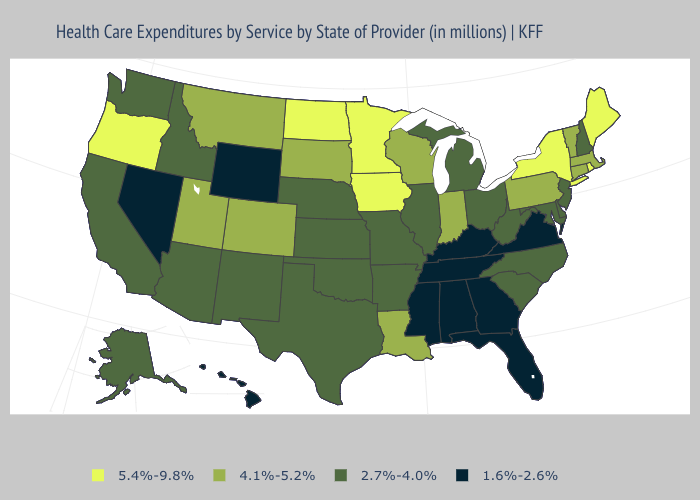What is the value of New York?
Give a very brief answer. 5.4%-9.8%. Does Nebraska have a higher value than New York?
Keep it brief. No. Name the states that have a value in the range 5.4%-9.8%?
Be succinct. Iowa, Maine, Minnesota, New York, North Dakota, Oregon, Rhode Island. What is the value of Wisconsin?
Write a very short answer. 4.1%-5.2%. Among the states that border Nevada , does Oregon have the highest value?
Short answer required. Yes. What is the value of Wisconsin?
Write a very short answer. 4.1%-5.2%. Does Massachusetts have the lowest value in the Northeast?
Answer briefly. No. What is the value of Hawaii?
Short answer required. 1.6%-2.6%. Name the states that have a value in the range 4.1%-5.2%?
Be succinct. Colorado, Connecticut, Indiana, Louisiana, Massachusetts, Montana, Pennsylvania, South Dakota, Utah, Vermont, Wisconsin. Name the states that have a value in the range 1.6%-2.6%?
Write a very short answer. Alabama, Florida, Georgia, Hawaii, Kentucky, Mississippi, Nevada, Tennessee, Virginia, Wyoming. Which states have the lowest value in the South?
Give a very brief answer. Alabama, Florida, Georgia, Kentucky, Mississippi, Tennessee, Virginia. Name the states that have a value in the range 2.7%-4.0%?
Answer briefly. Alaska, Arizona, Arkansas, California, Delaware, Idaho, Illinois, Kansas, Maryland, Michigan, Missouri, Nebraska, New Hampshire, New Jersey, New Mexico, North Carolina, Ohio, Oklahoma, South Carolina, Texas, Washington, West Virginia. Name the states that have a value in the range 2.7%-4.0%?
Quick response, please. Alaska, Arizona, Arkansas, California, Delaware, Idaho, Illinois, Kansas, Maryland, Michigan, Missouri, Nebraska, New Hampshire, New Jersey, New Mexico, North Carolina, Ohio, Oklahoma, South Carolina, Texas, Washington, West Virginia. Name the states that have a value in the range 1.6%-2.6%?
Quick response, please. Alabama, Florida, Georgia, Hawaii, Kentucky, Mississippi, Nevada, Tennessee, Virginia, Wyoming. Name the states that have a value in the range 1.6%-2.6%?
Short answer required. Alabama, Florida, Georgia, Hawaii, Kentucky, Mississippi, Nevada, Tennessee, Virginia, Wyoming. 